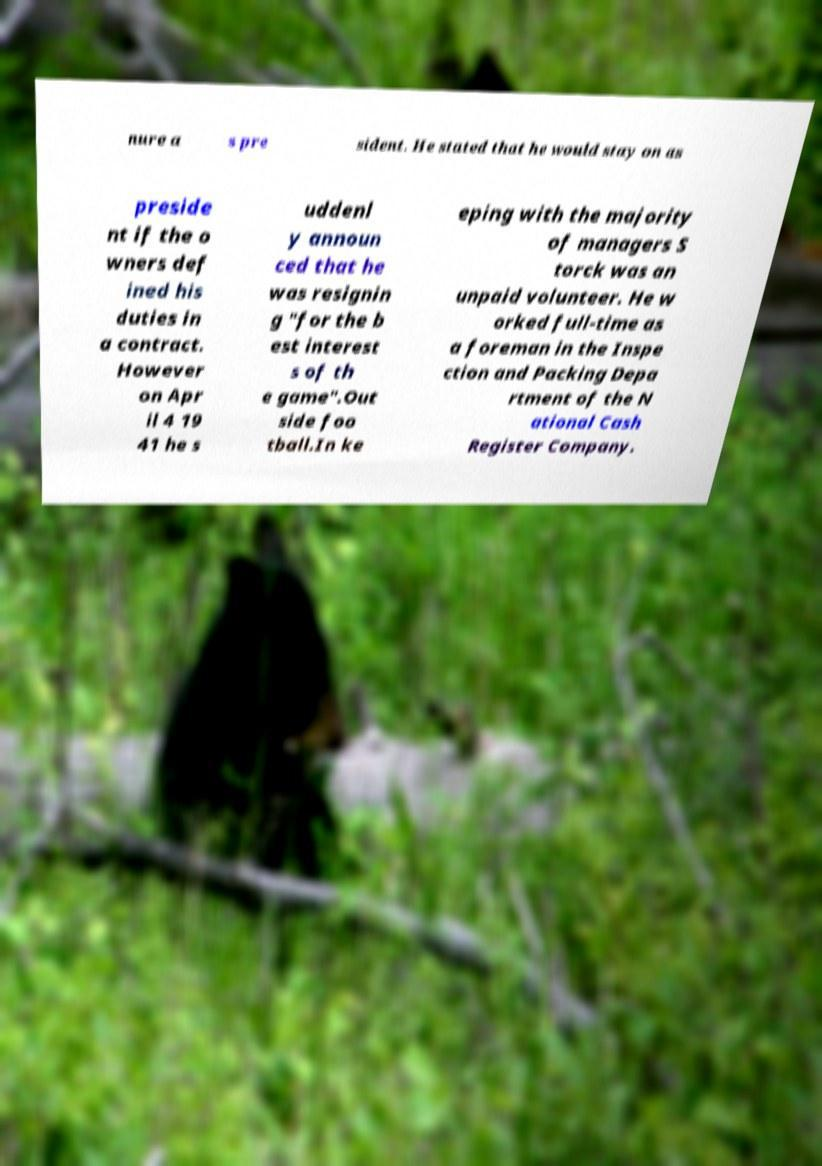Please read and relay the text visible in this image. What does it say? nure a s pre sident. He stated that he would stay on as preside nt if the o wners def ined his duties in a contract. However on Apr il 4 19 41 he s uddenl y announ ced that he was resignin g "for the b est interest s of th e game".Out side foo tball.In ke eping with the majority of managers S torck was an unpaid volunteer. He w orked full-time as a foreman in the Inspe ction and Packing Depa rtment of the N ational Cash Register Company. 